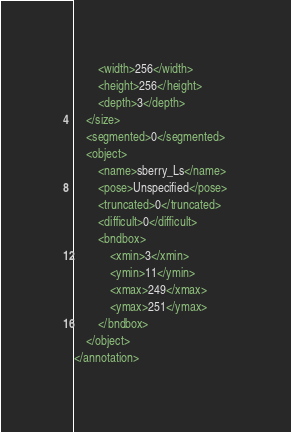Convert code to text. <code><loc_0><loc_0><loc_500><loc_500><_XML_>		<width>256</width>
		<height>256</height>
		<depth>3</depth>
	</size>
	<segmented>0</segmented>
	<object>
		<name>sberry_Ls</name>
		<pose>Unspecified</pose>
		<truncated>0</truncated>
		<difficult>0</difficult>
		<bndbox>
			<xmin>3</xmin>
			<ymin>11</ymin>
			<xmax>249</xmax>
			<ymax>251</ymax>
		</bndbox>
	</object>
</annotation>
</code> 